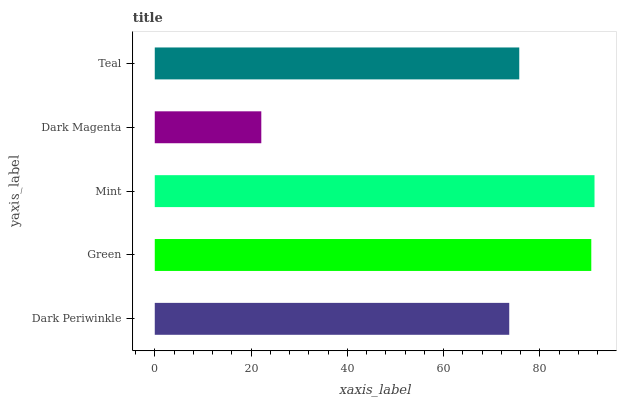Is Dark Magenta the minimum?
Answer yes or no. Yes. Is Mint the maximum?
Answer yes or no. Yes. Is Green the minimum?
Answer yes or no. No. Is Green the maximum?
Answer yes or no. No. Is Green greater than Dark Periwinkle?
Answer yes or no. Yes. Is Dark Periwinkle less than Green?
Answer yes or no. Yes. Is Dark Periwinkle greater than Green?
Answer yes or no. No. Is Green less than Dark Periwinkle?
Answer yes or no. No. Is Teal the high median?
Answer yes or no. Yes. Is Teal the low median?
Answer yes or no. Yes. Is Green the high median?
Answer yes or no. No. Is Dark Periwinkle the low median?
Answer yes or no. No. 